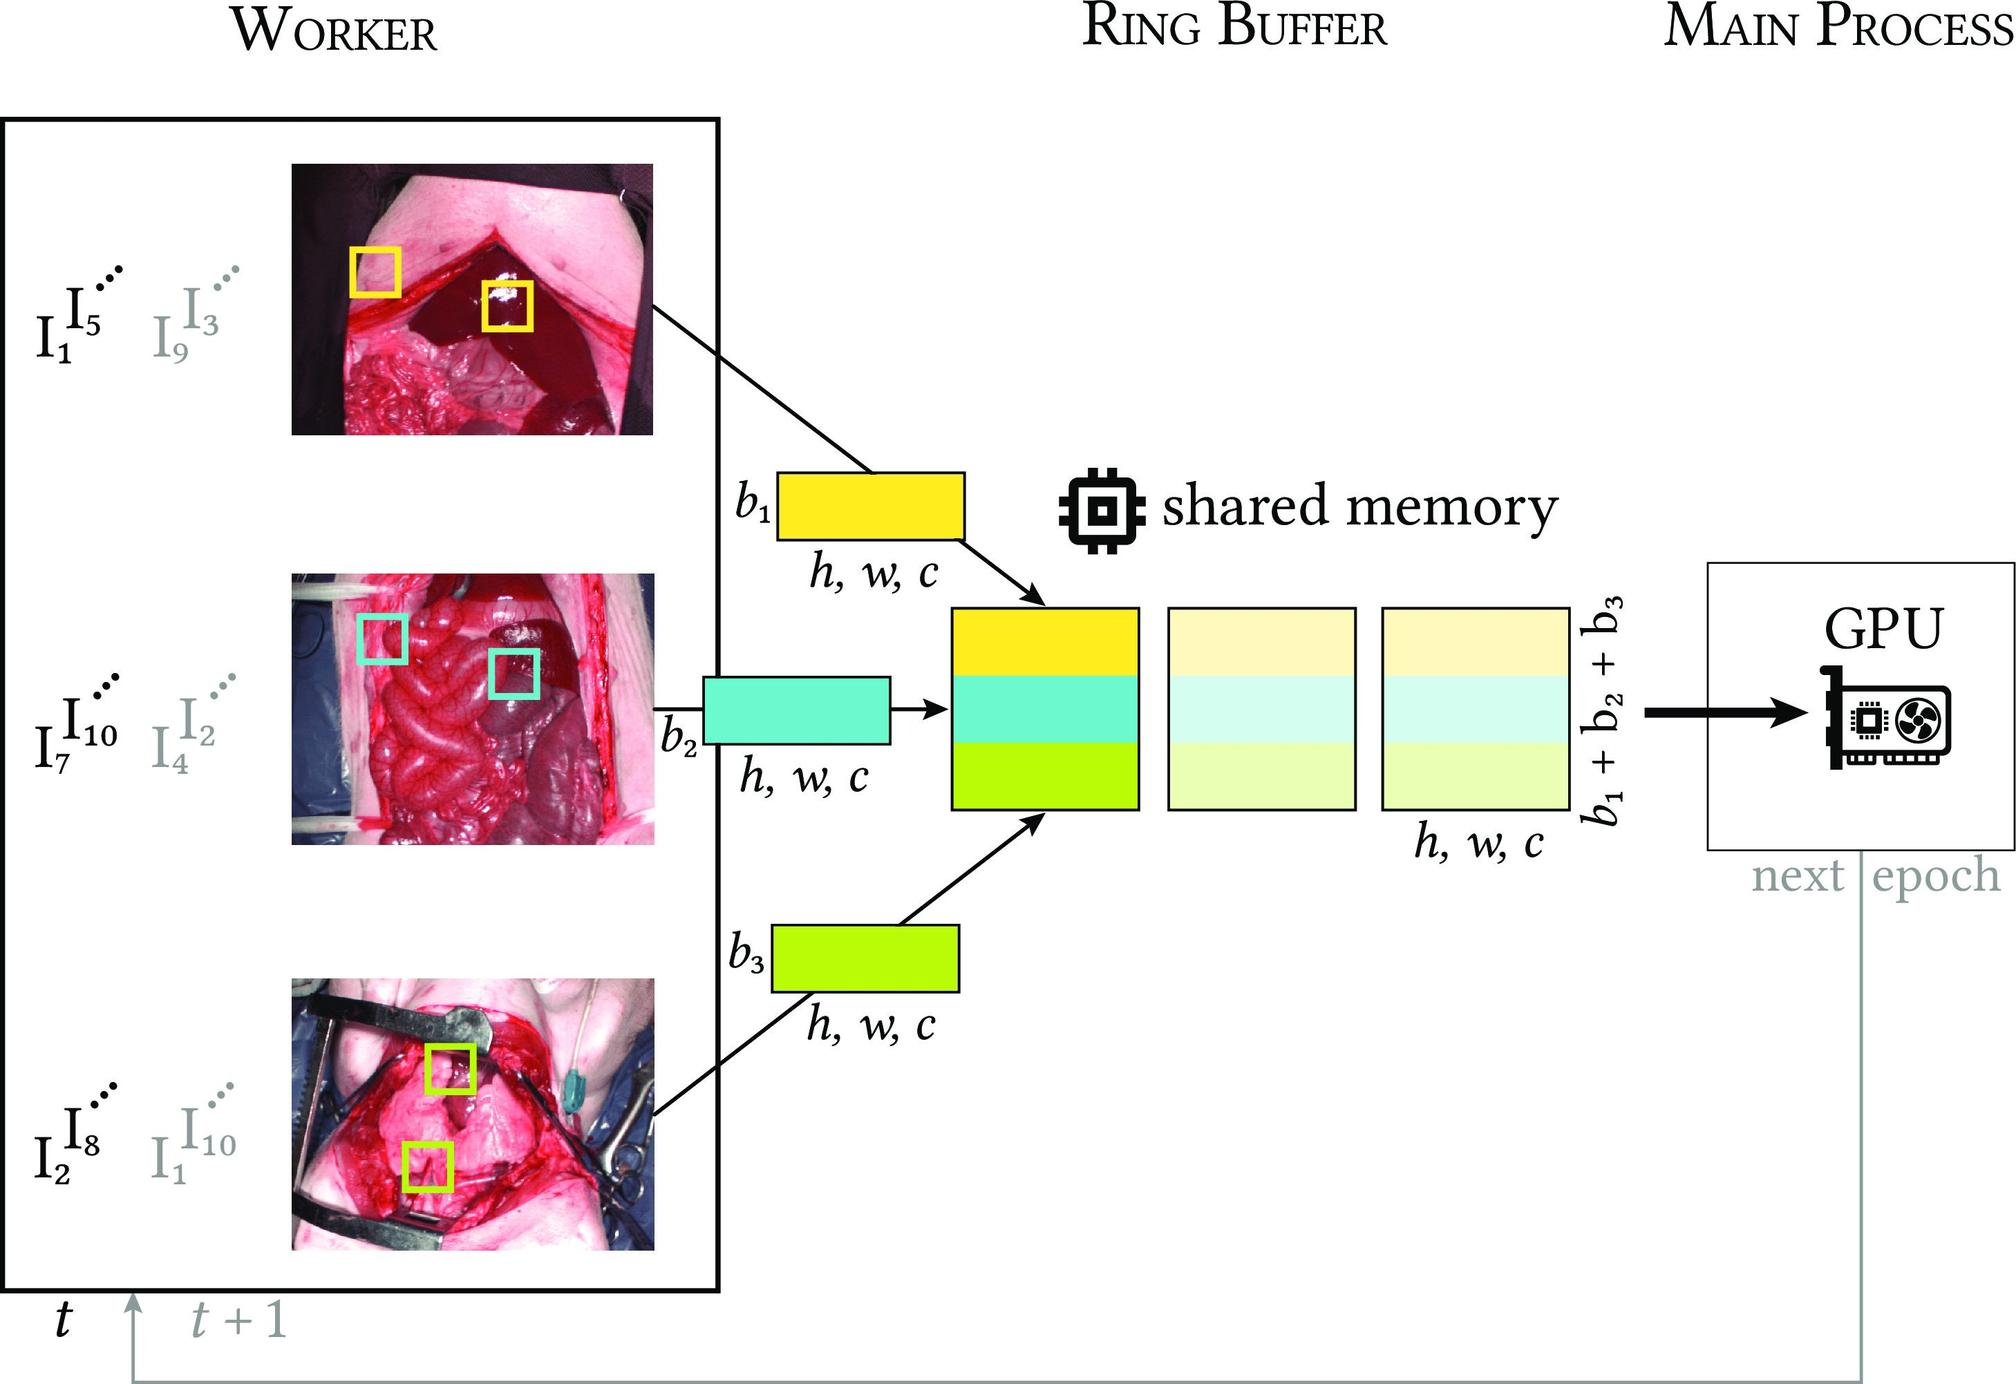Could you elaborate on the role of the GPU in this diagram? The GPU, or Graphics Processing Unit, shown at the right end of the diagram, is integral to processing the image data efficiently. In this architecture, the GPU is responsible for executing complex algorithms on the image batches received from the ring buffer. The high computational power of GPUs makes them suitable for performing intricate analysis and processing tasks quickly. This setup allows for accelerated image processing, which is critical in time-sensitive applications such as real-time medical imaging or automated visual inspections. 